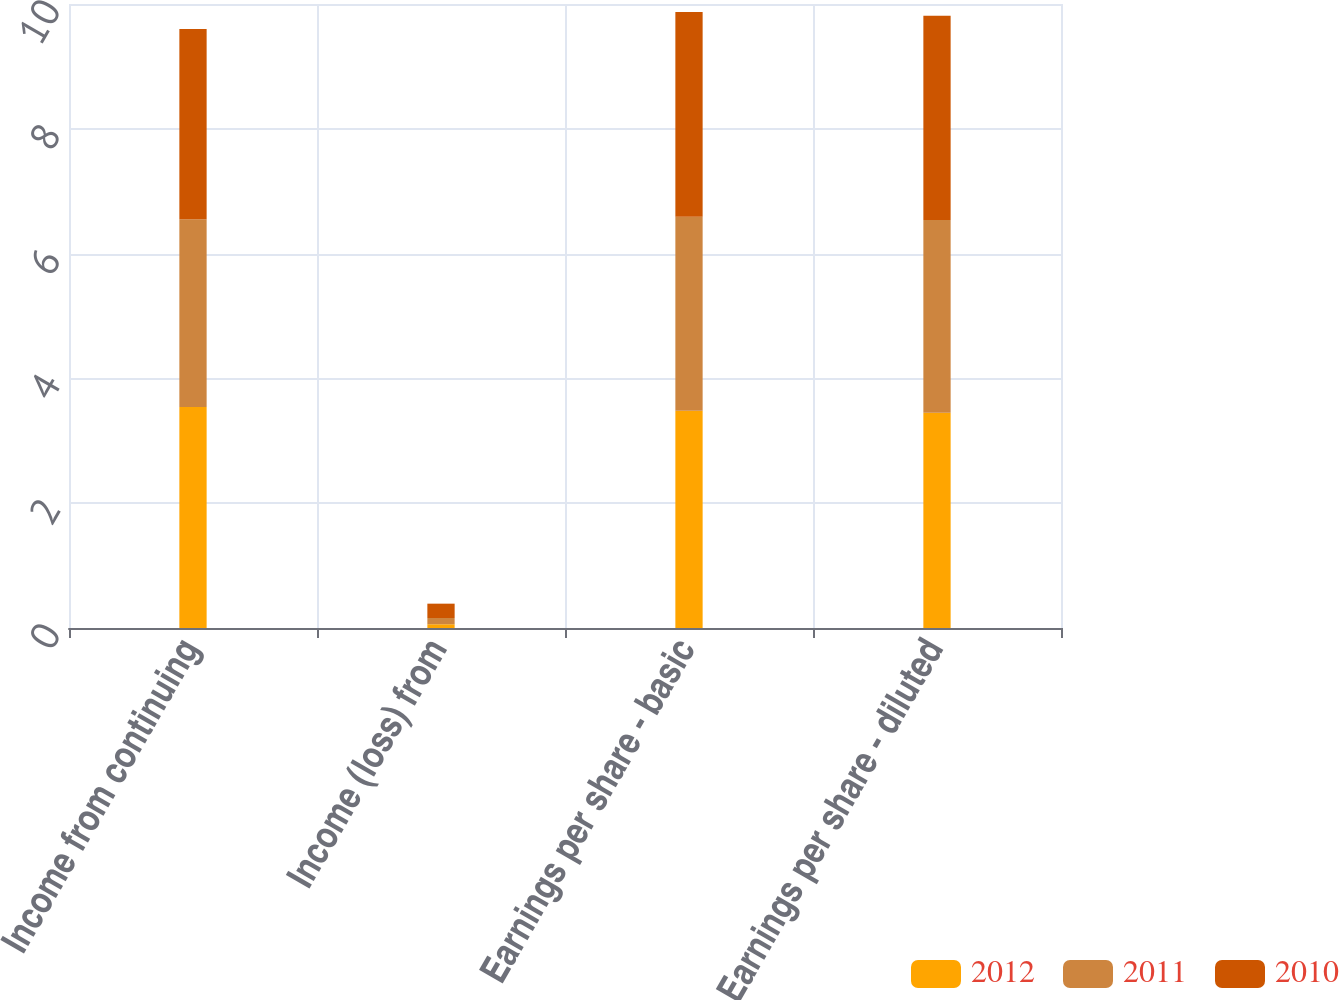Convert chart to OTSL. <chart><loc_0><loc_0><loc_500><loc_500><stacked_bar_chart><ecel><fcel>Income from continuing<fcel>Income (loss) from<fcel>Earnings per share - basic<fcel>Earnings per share - diluted<nl><fcel>2012<fcel>3.54<fcel>0.06<fcel>3.48<fcel>3.45<nl><fcel>2011<fcel>3.01<fcel>0.1<fcel>3.11<fcel>3.09<nl><fcel>2010<fcel>3.05<fcel>0.23<fcel>3.28<fcel>3.27<nl></chart> 